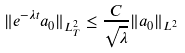<formula> <loc_0><loc_0><loc_500><loc_500>\| e ^ { - \lambda t } a _ { 0 } \| _ { L ^ { 2 } _ { T } } \leq \frac { C } { \sqrt { \lambda } } \| a _ { 0 } \| _ { L ^ { 2 } }</formula> 